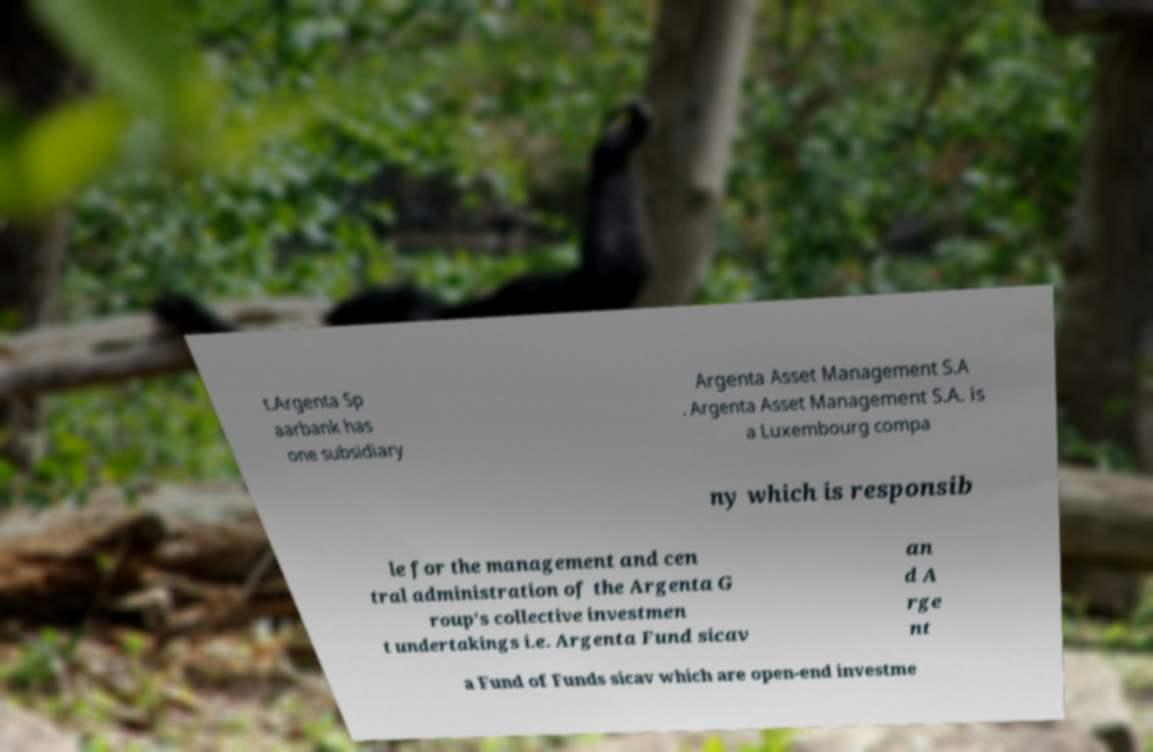Please read and relay the text visible in this image. What does it say? t.Argenta Sp aarbank has one subsidiary Argenta Asset Management S.A . Argenta Asset Management S.A. is a Luxembourg compa ny which is responsib le for the management and cen tral administration of the Argenta G roup's collective investmen t undertakings i.e. Argenta Fund sicav an d A rge nt a Fund of Funds sicav which are open-end investme 